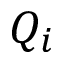Convert formula to latex. <formula><loc_0><loc_0><loc_500><loc_500>Q _ { i }</formula> 